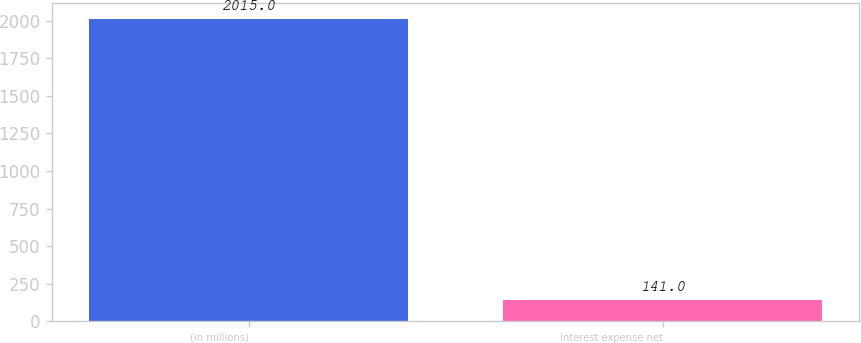<chart> <loc_0><loc_0><loc_500><loc_500><bar_chart><fcel>(in millions)<fcel>Interest expense net<nl><fcel>2015<fcel>141<nl></chart> 